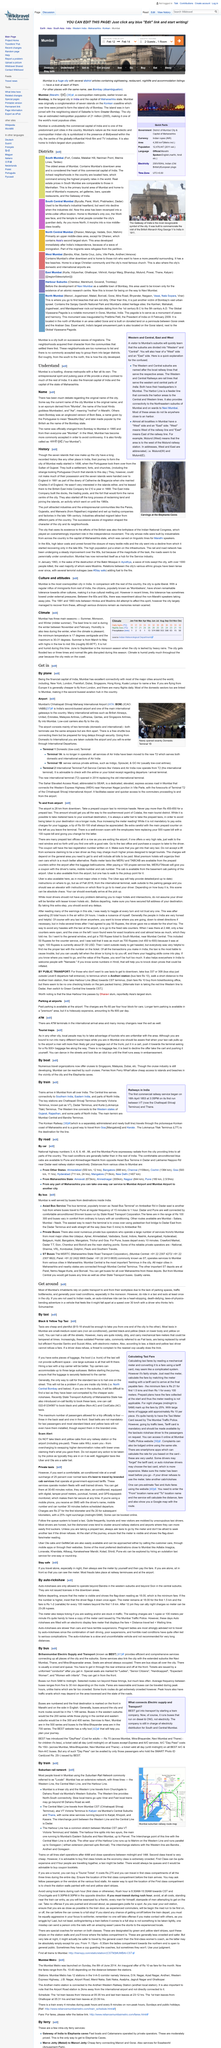Identify some key points in this picture. The first commercial railway service in India began on April 16, 1853. Mumbai citizens rely heavily on public transportation for their daily commute to work due to the lack of available parking spaces, the resultant traffic congestion, and the poor road conditions. The picture depicts the Mumbai suburban railway route map. The article "Get Around" calls the auto-rickshaw a "heart stopping" method of transportation. The three main seasons in Mumbai are Summer, Monsoon, and Winter, during which the city experiences a mild summer. 